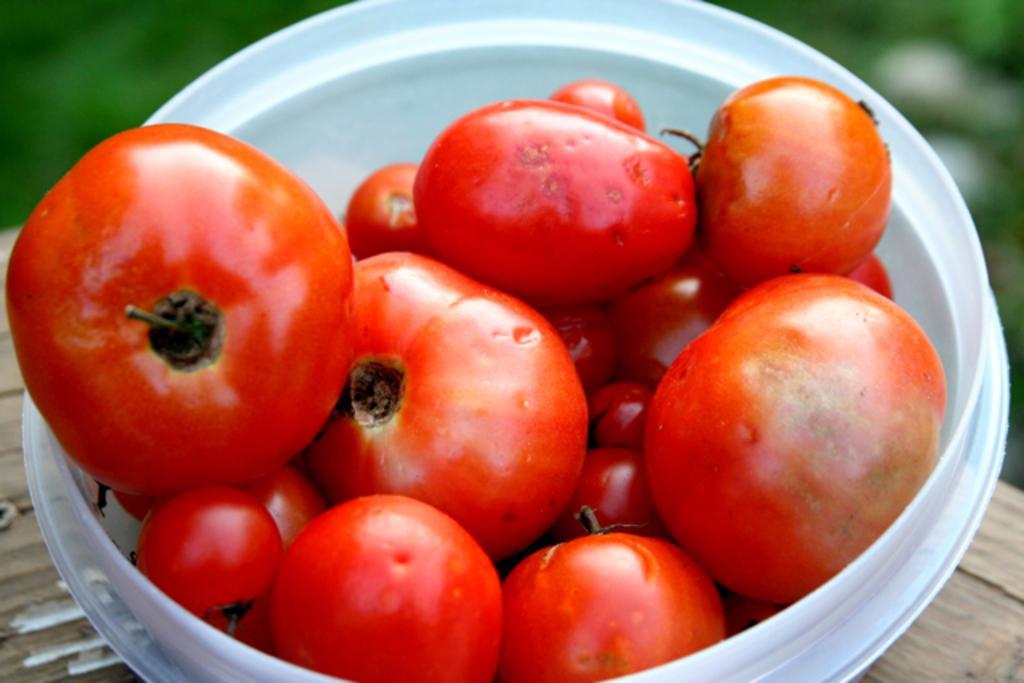Describe this image in one or two sentences. In this image, we can see a white bowl with tomatoes is placed on the wooden surface. Background there is a blur view. Here we can see greenery. 